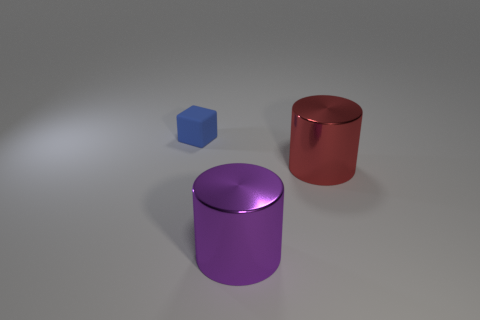How many objects are behind the red metallic cylinder and in front of the blue matte block?
Offer a terse response. 0. What number of objects are either objects that are right of the small blue block or tiny objects on the left side of the big red cylinder?
Make the answer very short. 3. How many other things are there of the same size as the red cylinder?
Give a very brief answer. 1. There is a big metal thing that is right of the thing that is in front of the big red cylinder; what is its shape?
Give a very brief answer. Cylinder. There is a large cylinder on the right side of the large purple thing; does it have the same color as the large metal object in front of the red metallic object?
Your answer should be compact. No. Is there any other thing that is the same color as the small cube?
Offer a very short reply. No. What color is the tiny object?
Offer a very short reply. Blue. Is there a tiny blue object?
Provide a succinct answer. Yes. There is a tiny cube; are there any big cylinders to the left of it?
Offer a very short reply. No. There is another thing that is the same shape as the big purple thing; what material is it?
Offer a terse response. Metal. 